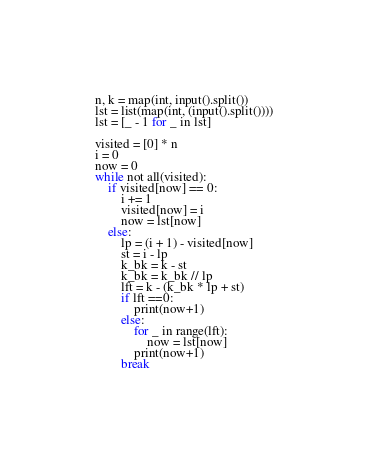Convert code to text. <code><loc_0><loc_0><loc_500><loc_500><_Python_>n, k = map(int, input().split())
lst = list(map(int, (input().split())))
lst = [_ - 1 for _ in lst]

visited = [0] * n
i = 0
now = 0
while not all(visited):
    if visited[now] == 0:
        i += 1
        visited[now] = i
        now = lst[now] 
    else:
        lp = (i + 1) - visited[now]
        st = i - lp
        k_bk = k - st
        k_bk = k_bk // lp
        lft = k - (k_bk * lp + st)
        if lft ==0:
            print(now+1)
        else:
            for _ in range(lft):
                now = lst[now]
            print(now+1)
        break</code> 